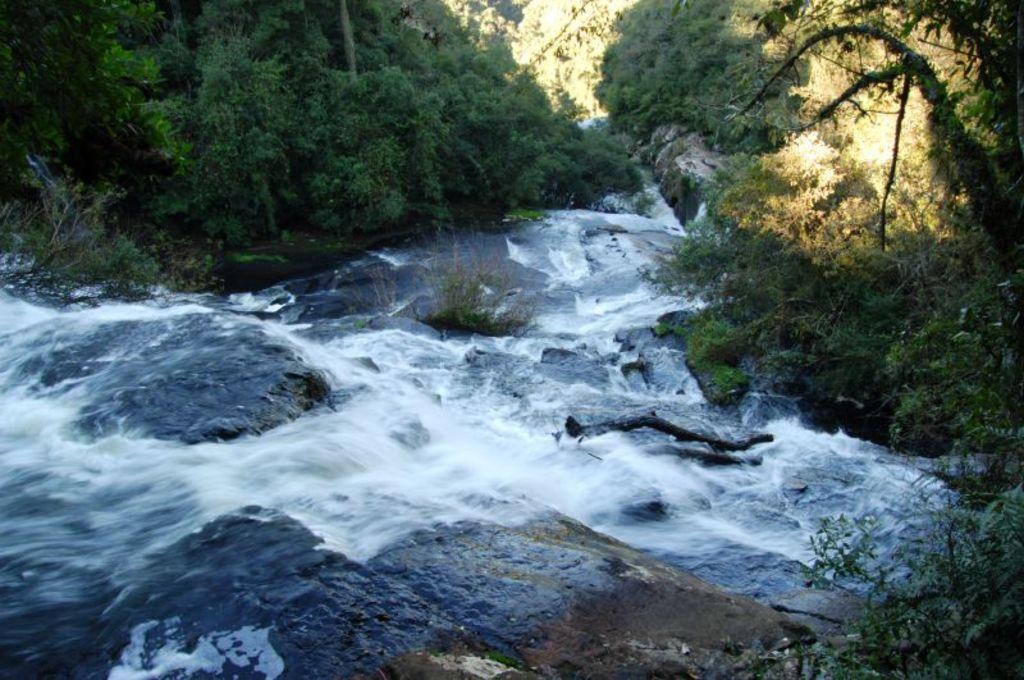What type of natural elements can be seen in the image? There are rocks, water, and trees visible in the image. Can you describe the water in the image? The water is visible in the image, but its specific characteristics are not mentioned. What type of vegetation is present in the image? Trees are present in the image. How many houses can be seen falling into the water in the image? There are no houses present in the image, nor is there any indication of anything falling into the water. 